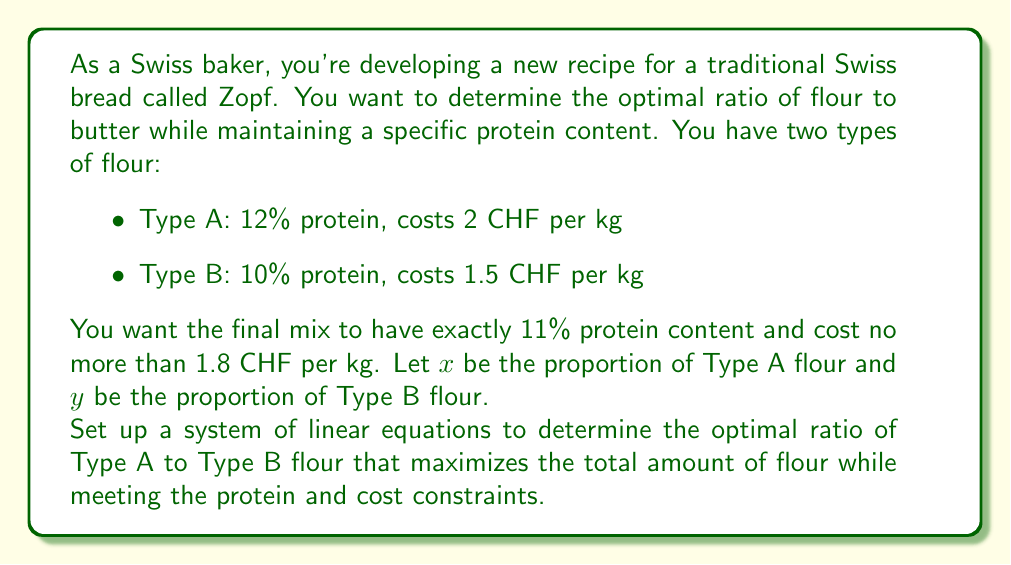Can you answer this question? Let's approach this step-by-step:

1) First, we need to set up the equations based on the given information:

   a) For the protein content:
      $$12x + 10y = 11(x + y)$$

   b) For the cost constraint:
      $$2x + 1.5y \leq 1.8(x + y)$$

   c) The proportions must sum to 1:
      $$x + y = 1$$

2) Let's simplify the protein content equation:
   $$12x + 10y = 11x + 11y$$
   $$12x - 11x = 11y - 10y$$
   $$x = y$$

3) This means the optimal ratio is 1:1, or 50% of each type of flour.

4) Let's verify if this satisfies the cost constraint:
   $$2(0.5) + 1.5(0.5) \leq 1.8(0.5 + 0.5)$$
   $$1 + 0.75 \leq 1.8$$
   $$1.75 \leq 1.8$$

   Indeed, it does satisfy the cost constraint.

5) To express this as a ratio, we can say Type A : Type B = 1 : 1
Answer: The optimal ratio of Type A flour to Type B flour is 1:1, or 50% of each type. 